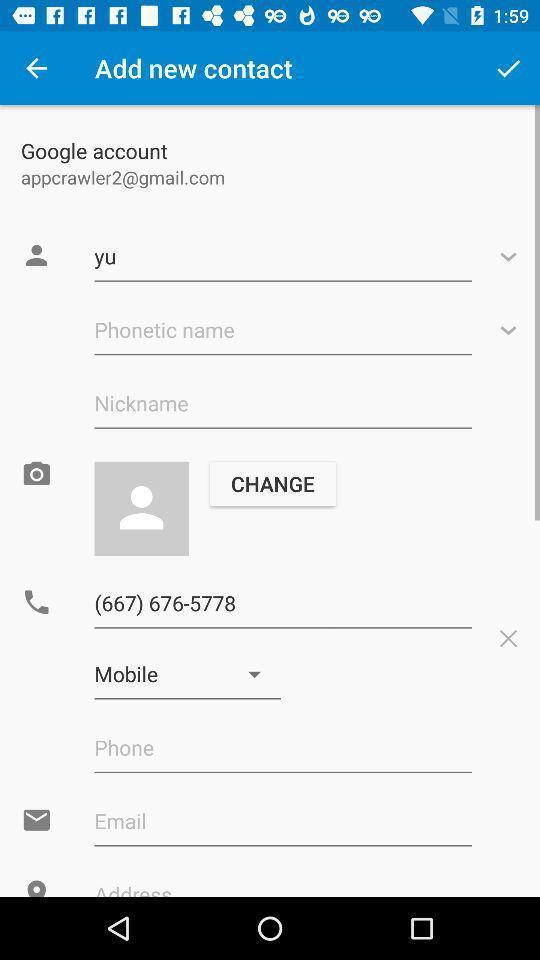Tell me about the visual elements in this screen capture. Page showing profile page. 